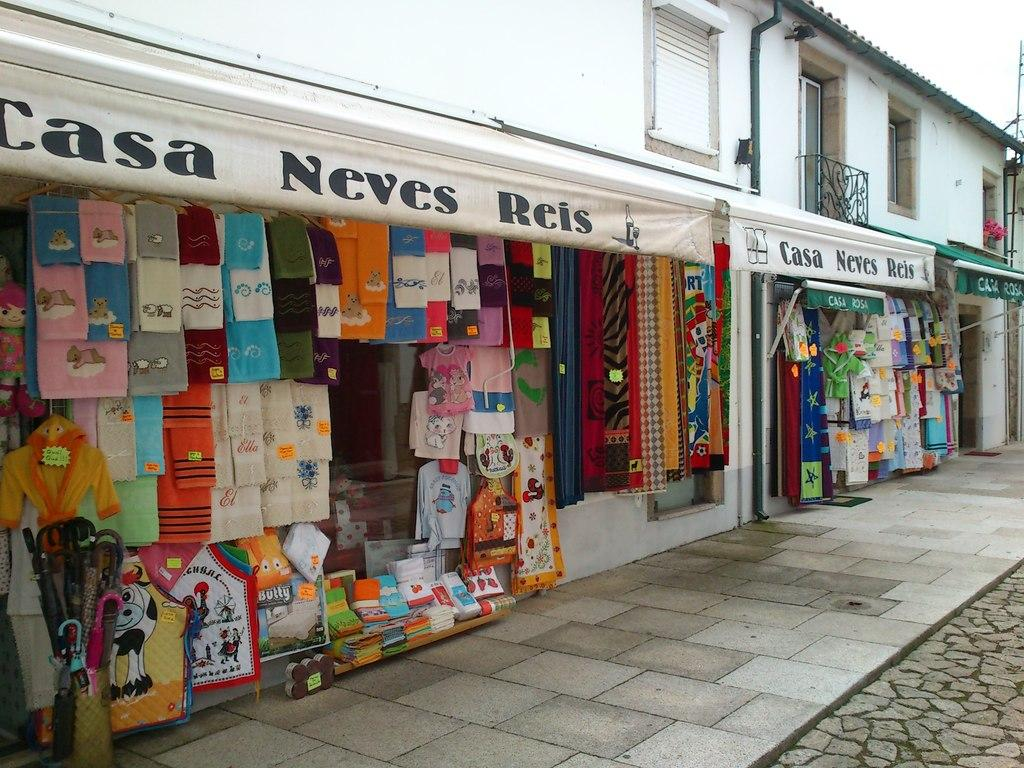Provide a one-sentence caption for the provided image. The Casa Neves Reis store offers an assortment of shirt and towel products. 